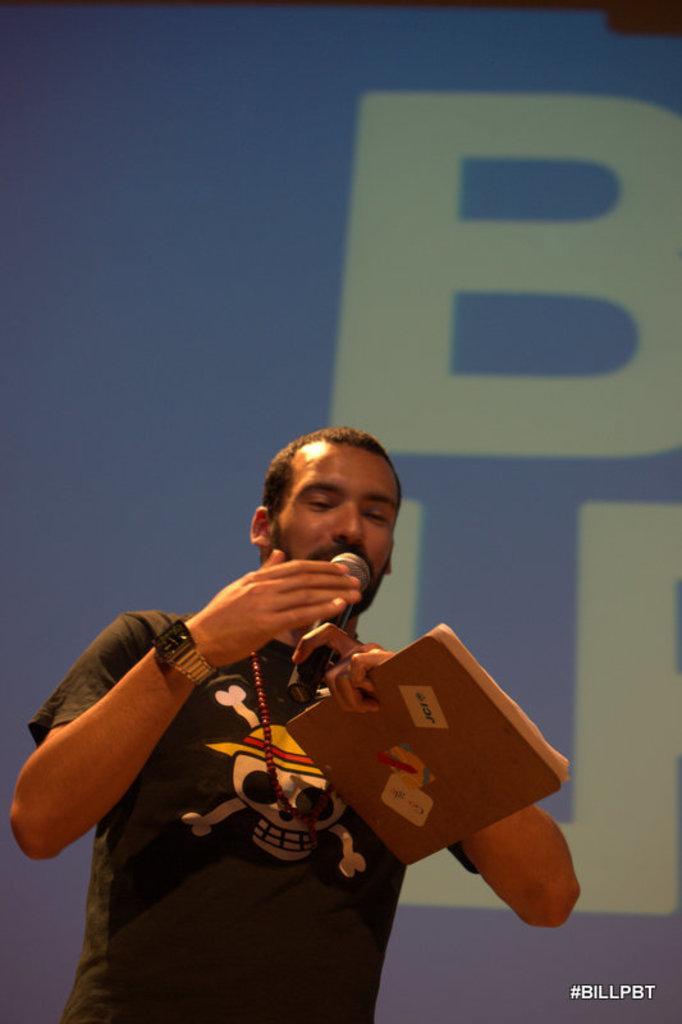Describe this image in one or two sentences. In this image there is a man in the middle who is holding the book with one hand and a mic with another hand. He kept the mic near to his mouth. In the background it looks like a screen. 